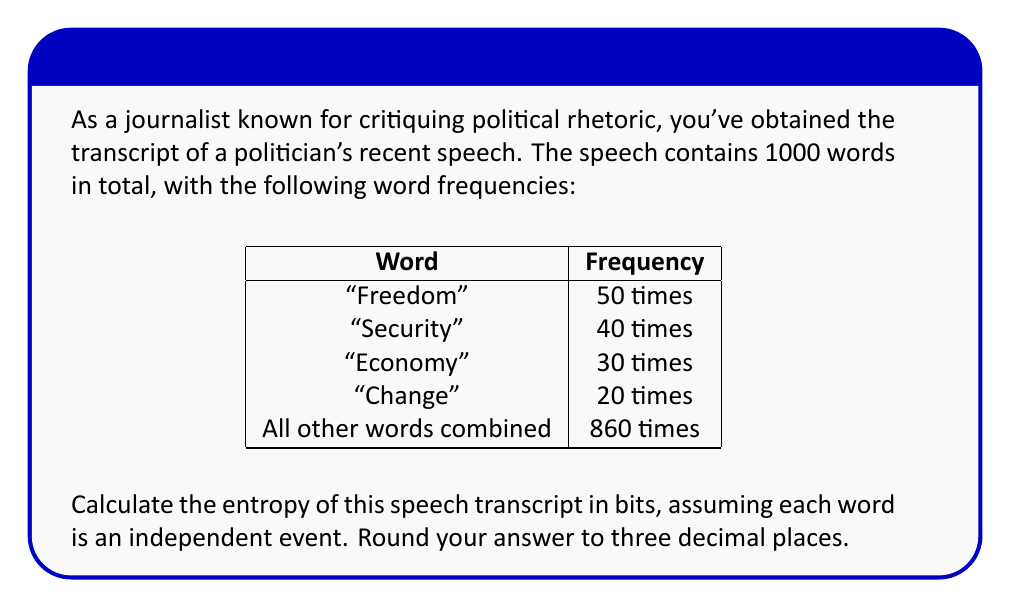Help me with this question. To calculate the entropy of the speech transcript, we'll use Shannon's entropy formula:

$$H = -\sum_{i=1}^n p_i \log_2(p_i)$$

Where $p_i$ is the probability of each word occurring.

Step 1: Calculate the probabilities for each word category:
- P("Freedom") = 50/1000 = 0.05
- P("Security") = 40/1000 = 0.04
- P("Economy") = 30/1000 = 0.03
- P("Change") = 20/1000 = 0.02
- P(Other words) = 860/1000 = 0.86

Step 2: Apply the entropy formula:

$$\begin{align*}
H &= -[0.05 \log_2(0.05) + 0.04 \log_2(0.04) + 0.03 \log_2(0.03) \\
&+ 0.02 \log_2(0.02) + 0.86 \log_2(0.86)]
\end{align*}$$

Step 3: Calculate each term:
- $0.05 \log_2(0.05) \approx -0.2161$
- $0.04 \log_2(0.04) \approx -0.1856$
- $0.03 \log_2(0.03) \approx -0.1517$
- $0.02 \log_2(0.02) \approx -0.1129$
- $0.86 \log_2(0.86) \approx -0.1723$

Step 4: Sum the negative of these values:

$$H = 0.2161 + 0.1856 + 0.1517 + 0.1129 + 0.1723 = 0.8386$$

Step 5: Round to three decimal places:

$$H \approx 0.839 \text{ bits}$$
Answer: 0.839 bits 